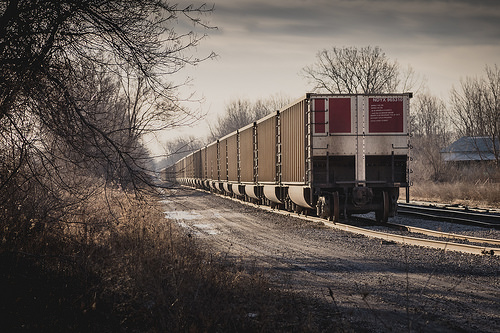<image>
Is there a train to the right of the tree? Yes. From this viewpoint, the train is positioned to the right side relative to the tree. 